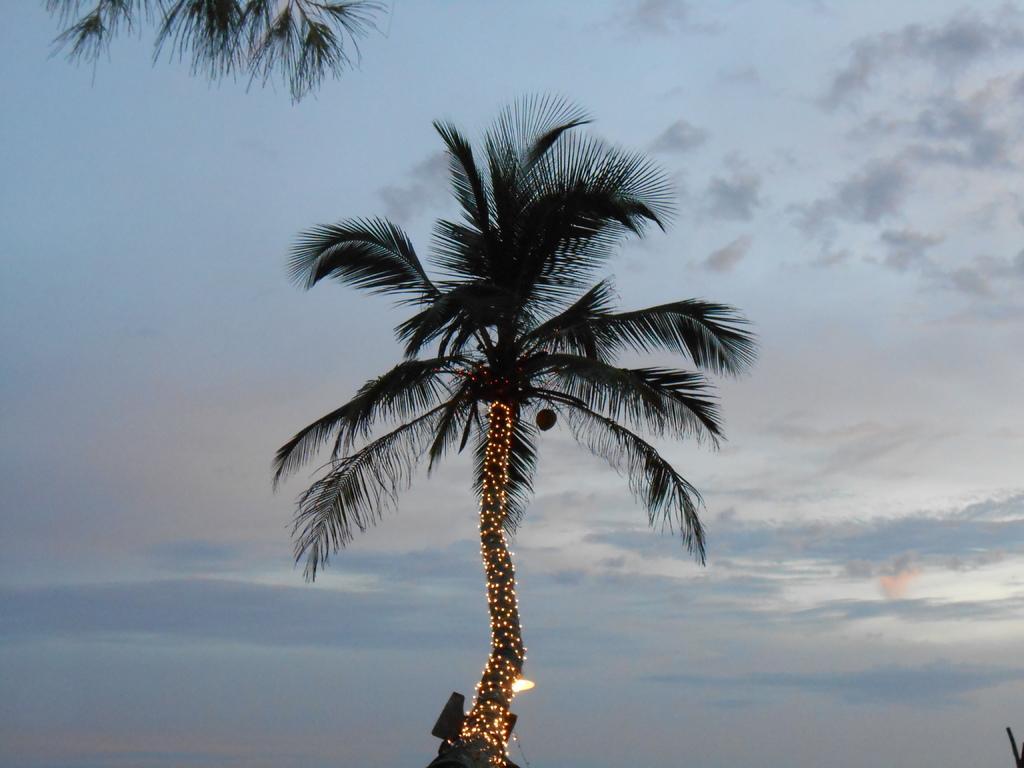In one or two sentences, can you explain what this image depicts? In the center of the image there is a tree. In the background of the image there is sky. 